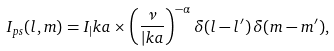<formula> <loc_0><loc_0><loc_500><loc_500>I _ { p s } ( l , m ) = I _ { | } k a \times \left ( \frac { \nu } { | k a } \right ) ^ { - \alpha } \delta ( l - l ^ { \prime } ) \, \delta ( m - m ^ { \prime } ) ,</formula> 